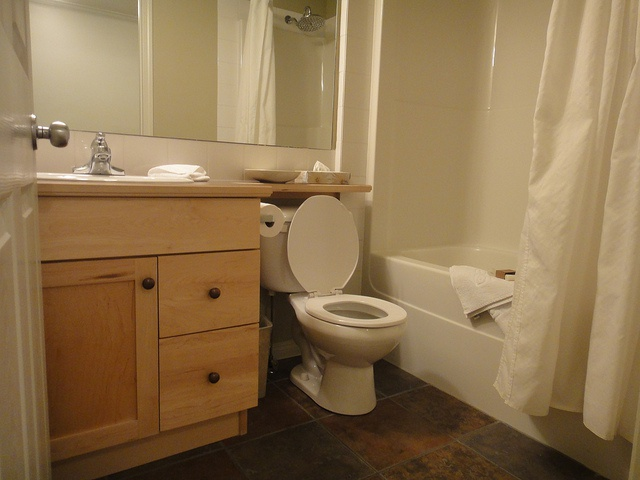Describe the objects in this image and their specific colors. I can see toilet in gray, tan, and maroon tones, sink in gray, ivory, and tan tones, bowl in gray, olive, brown, and tan tones, and bowl in gray, olive, tan, and brown tones in this image. 